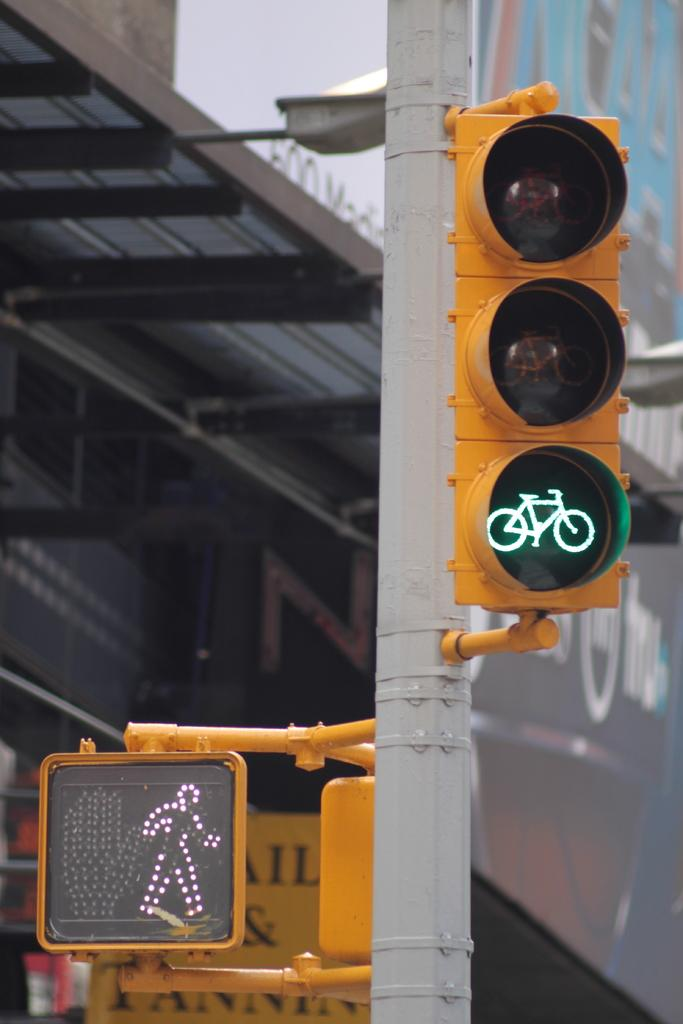<image>
Offer a succinct explanation of the picture presented. Pedestrian street signs showing a green bicycle and a walking man. 